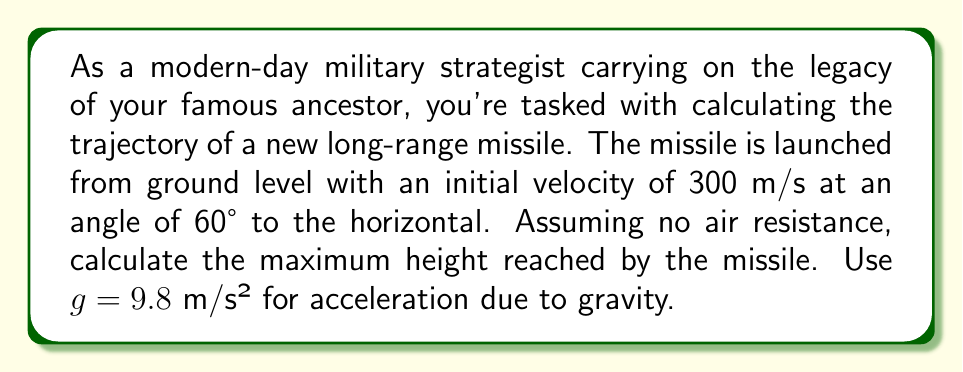Solve this math problem. Let's approach this step-by-step:

1) The trajectory of a projectile follows a parabolic path, which can be described by a quadratic equation. We'll use the equation:

   $$y = -\frac{1}{2}g\left(\frac{x}{v_x}\right)^2 + \tan(\theta)x + y_0$$

   Where:
   - $y$ is the vertical position
   - $x$ is the horizontal position
   - $g$ is the acceleration due to gravity (9.8 m/s²)
   - $v_x$ is the horizontal component of velocity
   - $\theta$ is the launch angle
   - $y_0$ is the initial height (0 in this case)

2) First, we need to find $v_x$:
   $$v_x = v \cos(\theta) = 300 \cos(60°) = 300 \cdot 0.5 = 150 \text{ m/s}$$

3) Now we can substitute these values into our equation:

   $$y = -\frac{1}{2}(9.8)\left(\frac{x}{150}\right)^2 + \tan(60°)x + 0$$

4) To find the maximum height, we need to find the vertex of this parabola. The x-coordinate of the vertex occurs when the derivative of y with respect to x is zero:

   $$\frac{dy}{dx} = -\frac{9.8}{150^2}x + \tan(60°) = 0$$

5) Solving for x:

   $$\frac{9.8}{150^2}x = \tan(60°)$$
   $$x = \frac{150^2 \tan(60°)}{9.8} \approx 3897.11 \text{ m}$$

6) Now we can substitute this x-value back into our original equation to find the maximum height:

   $$y_{\text{max}} = -\frac{1}{2}(9.8)\left(\frac{3897.11}{150}\right)^2 + \tan(60°)(3897.11) + 0$$

7) Simplifying:

   $$y_{\text{max}} = -1299.04 + 6746.15 = 5447.11 \text{ m}$$
Answer: The maximum height reached by the missile is approximately 5447.11 meters. 